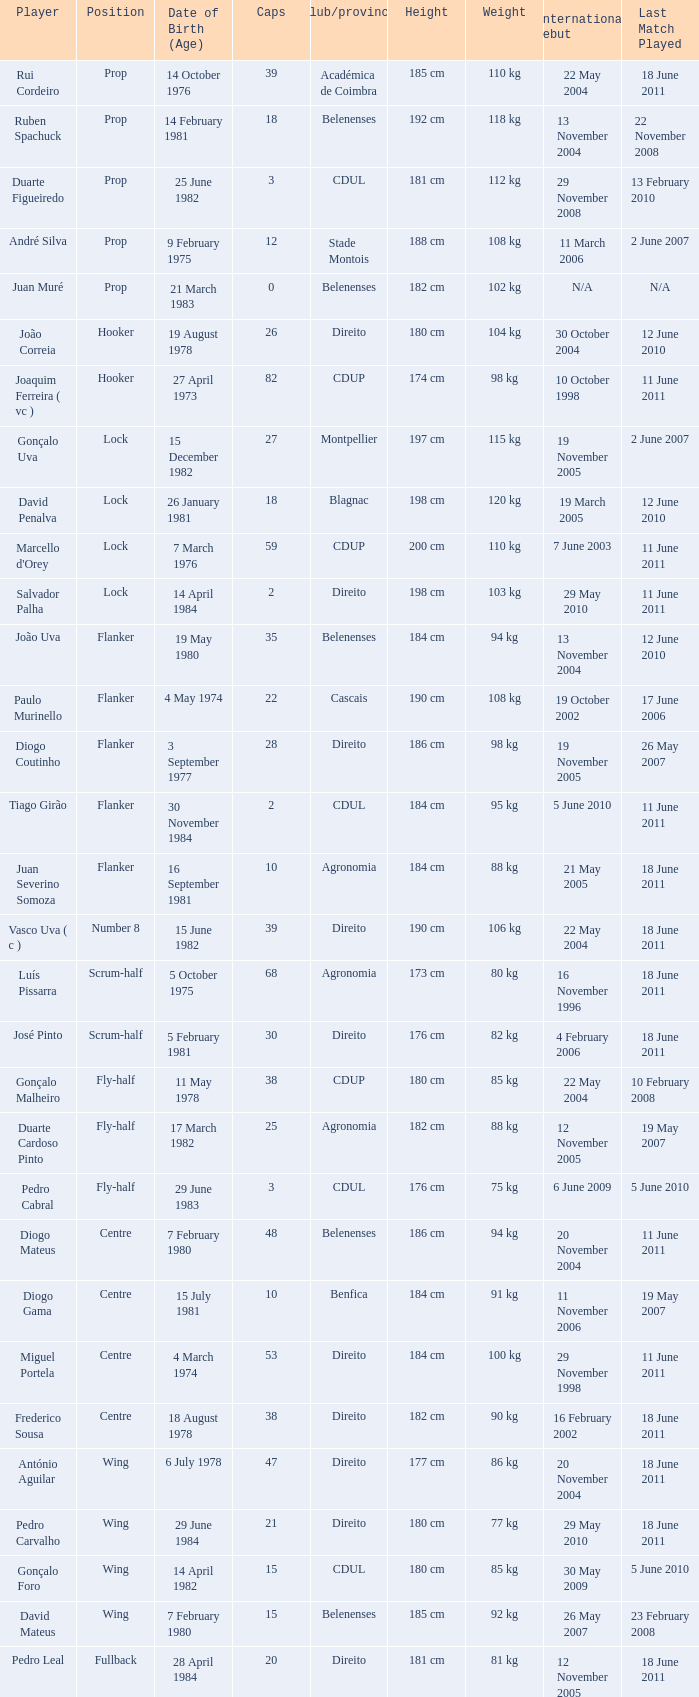How many caps have a Date of Birth (Age) of 15 july 1981? 1.0. 